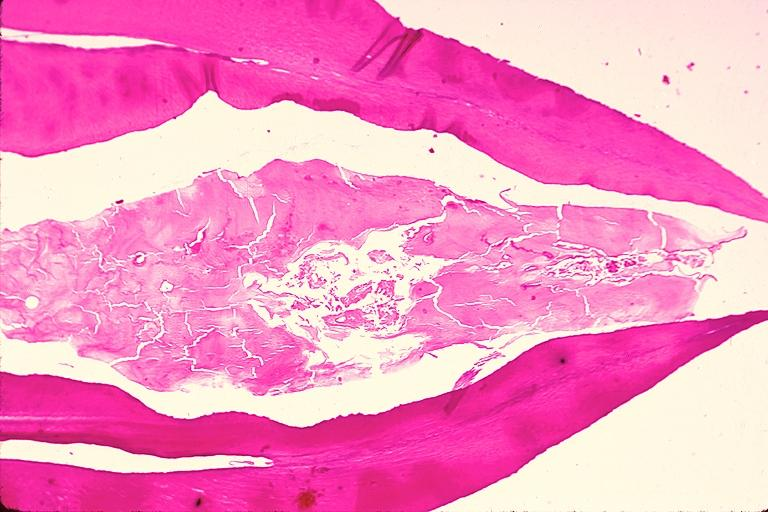what does this image show?
Answer the question using a single word or phrase. Dens invaginatus 